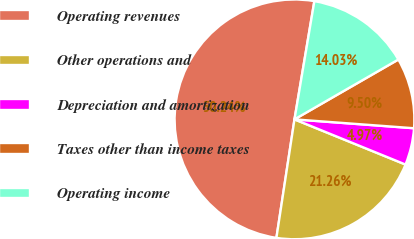Convert chart. <chart><loc_0><loc_0><loc_500><loc_500><pie_chart><fcel>Operating revenues<fcel>Other operations and<fcel>Depreciation and amortization<fcel>Taxes other than income taxes<fcel>Operating income<nl><fcel>50.25%<fcel>21.26%<fcel>4.97%<fcel>9.5%<fcel>14.03%<nl></chart> 